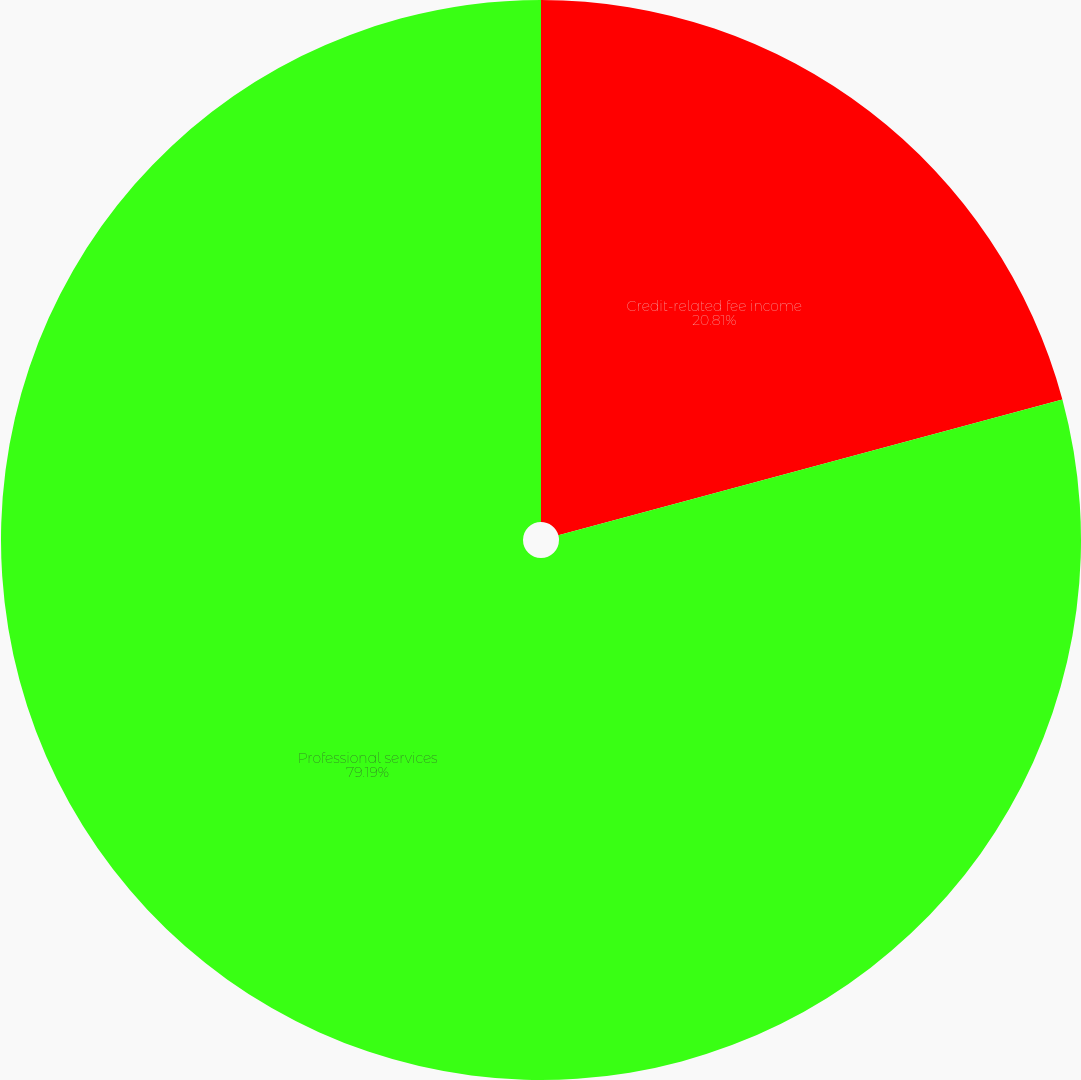Convert chart. <chart><loc_0><loc_0><loc_500><loc_500><pie_chart><fcel>Credit-related fee income<fcel>Professional services<nl><fcel>20.81%<fcel>79.19%<nl></chart> 